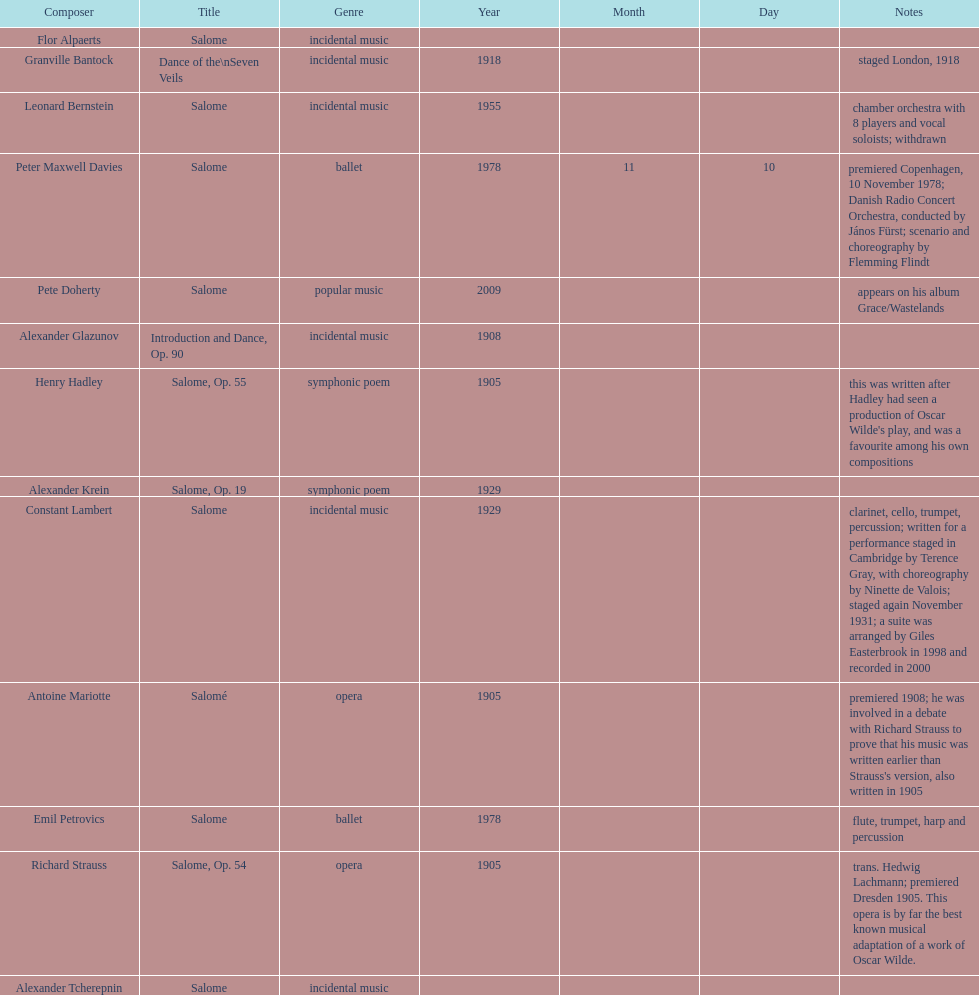How many works were made in the incidental music genre? 6. 